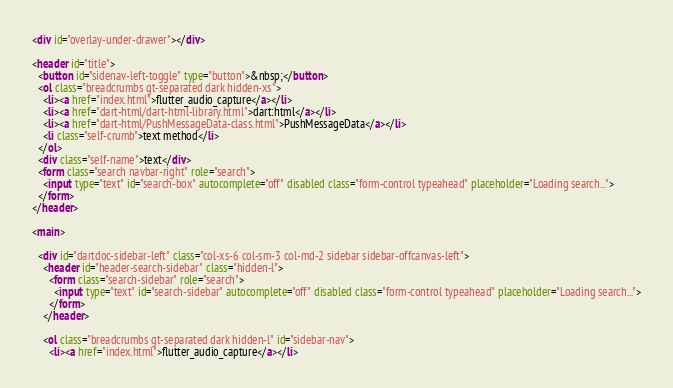<code> <loc_0><loc_0><loc_500><loc_500><_HTML_>
<div id="overlay-under-drawer"></div>

<header id="title">
  <button id="sidenav-left-toggle" type="button">&nbsp;</button>
  <ol class="breadcrumbs gt-separated dark hidden-xs">
    <li><a href="index.html">flutter_audio_capture</a></li>
    <li><a href="dart-html/dart-html-library.html">dart:html</a></li>
    <li><a href="dart-html/PushMessageData-class.html">PushMessageData</a></li>
    <li class="self-crumb">text method</li>
  </ol>
  <div class="self-name">text</div>
  <form class="search navbar-right" role="search">
    <input type="text" id="search-box" autocomplete="off" disabled class="form-control typeahead" placeholder="Loading search...">
  </form>
</header>

<main>

  <div id="dartdoc-sidebar-left" class="col-xs-6 col-sm-3 col-md-2 sidebar sidebar-offcanvas-left">
    <header id="header-search-sidebar" class="hidden-l">
      <form class="search-sidebar" role="search">
        <input type="text" id="search-sidebar" autocomplete="off" disabled class="form-control typeahead" placeholder="Loading search...">
      </form>
    </header>
    
    <ol class="breadcrumbs gt-separated dark hidden-l" id="sidebar-nav">
      <li><a href="index.html">flutter_audio_capture</a></li></code> 